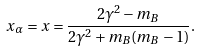<formula> <loc_0><loc_0><loc_500><loc_500>x _ { \alpha } = x = \frac { 2 \gamma ^ { 2 } - m _ { B } } { 2 \gamma ^ { 2 } + m _ { B } ( m _ { B } - 1 ) } .</formula> 